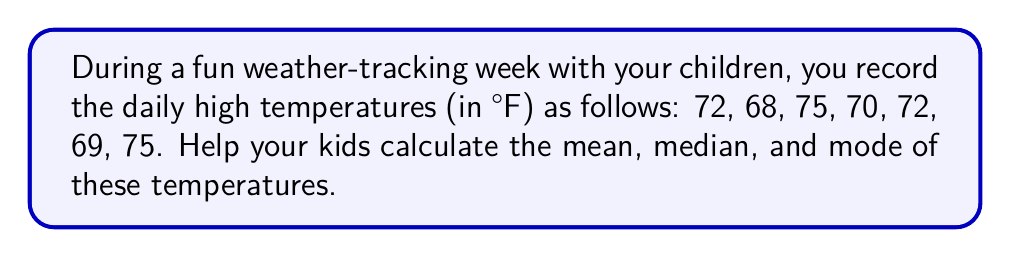Can you solve this math problem? Let's break this down step-by-step:

1. Mean:
   The mean is the average of all numbers.
   a) Add all temperatures: $72 + 68 + 75 + 70 + 72 + 69 + 75 = 501$
   b) Count the number of days: 7
   c) Divide the sum by the number of days: $\frac{501}{7} = 71.57$

2. Median:
   The median is the middle number when the data is ordered.
   a) Order the temperatures: 68, 69, 70, 72, 72, 75, 75
   b) With 7 numbers, the median is the 4th number
   c) The median is 72

3. Mode:
   The mode is the number that appears most frequently.
   a) Count occurrences: 68 (1), 69 (1), 70 (1), 72 (2), 75 (2)
   b) Both 72 and 75 appear twice, more than any other number

Therefore:
Mean = $71.57°F$
Median = $72°F$
Mode = $72°F$ and $75°F$ (bimodal)
Answer: Mean: $71.57°F$, Median: $72°F$, Mode: $72°F$ and $75°F$ 